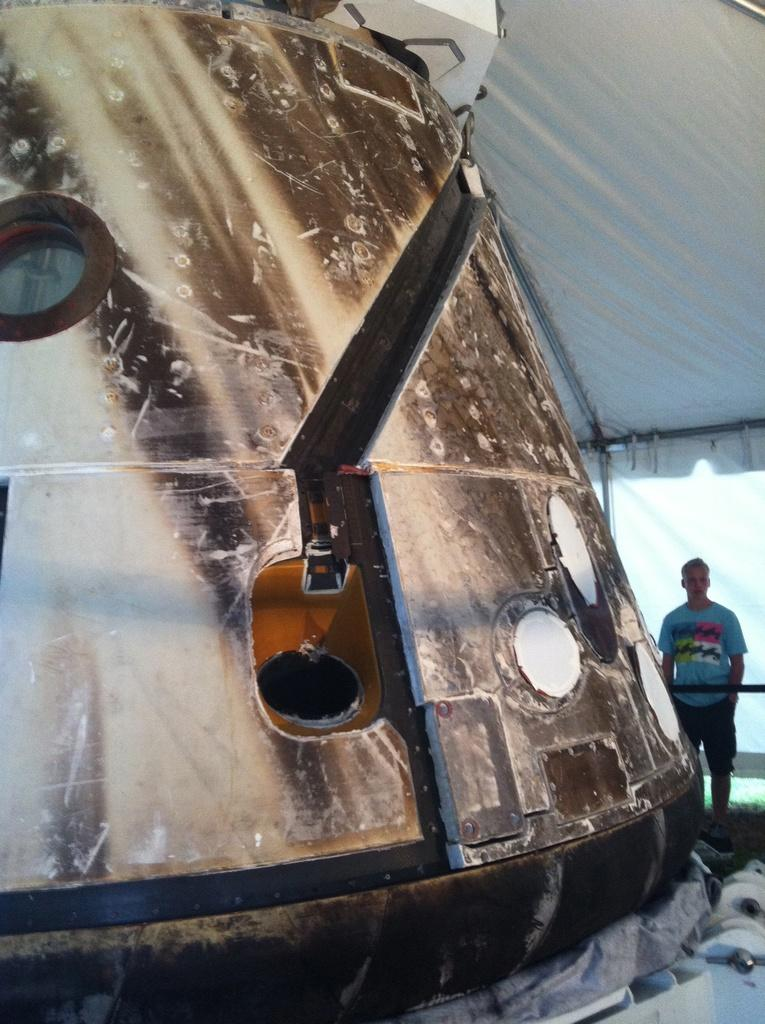What is the main subject in the image? There is an object in the image. Can you describe the person in the image? There is a person standing in the image. Where is the person standing in relation to the object? The person is standing under a tent. What type of star can be seen shining brightly in the image? There is no star visible in the image. 